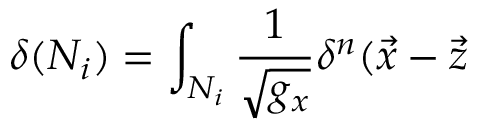<formula> <loc_0><loc_0><loc_500><loc_500>\delta ( N _ { i } ) = \int _ { N _ { i } } \frac { 1 } \sqrt { g _ { x } } } \delta ^ { n } ( \vec { x } - \vec { z }</formula> 